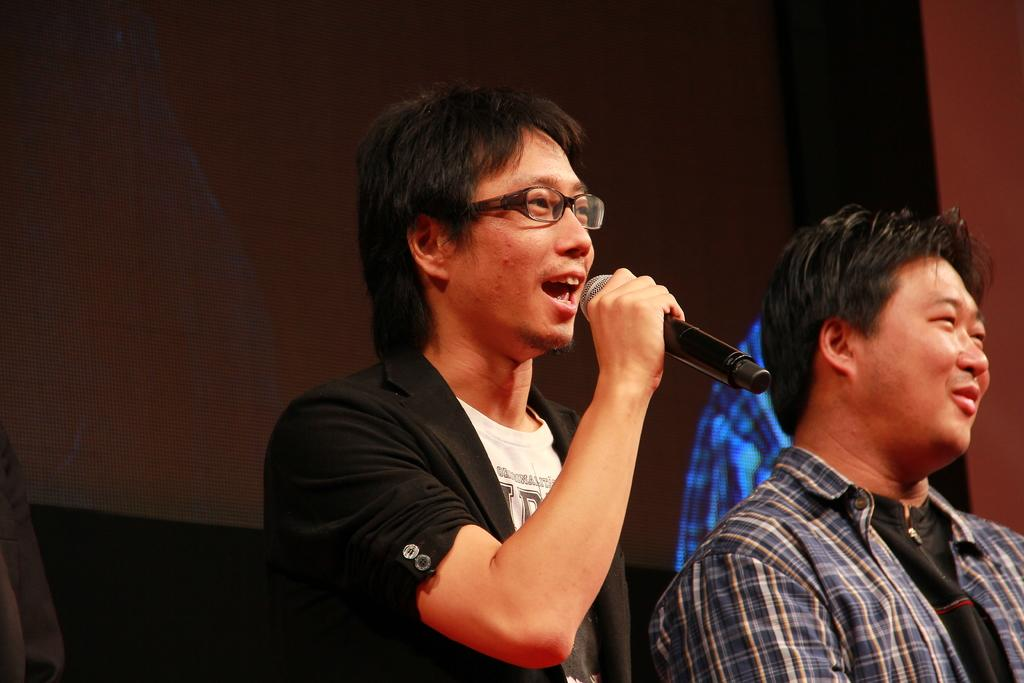How many people are in the image? There are two men in the image. What is the man in the white t-shirt and black coat wearing? The man in the white t-shirt and black coat is wearing a white t-shirt and a black coat. What is the man in the white t-shirt and black coat holding? The man in the white t-shirt and black coat is holding a microphone. What is the other man wearing? The other man is wearing a black t-shirt and a shirt. How many bikes can be seen in the image? There are no bikes present in the image. What type of wave is the man in the black t-shirt riding in the image? There is no wave or any indication of water in the image; it features two men standing on a surface. 